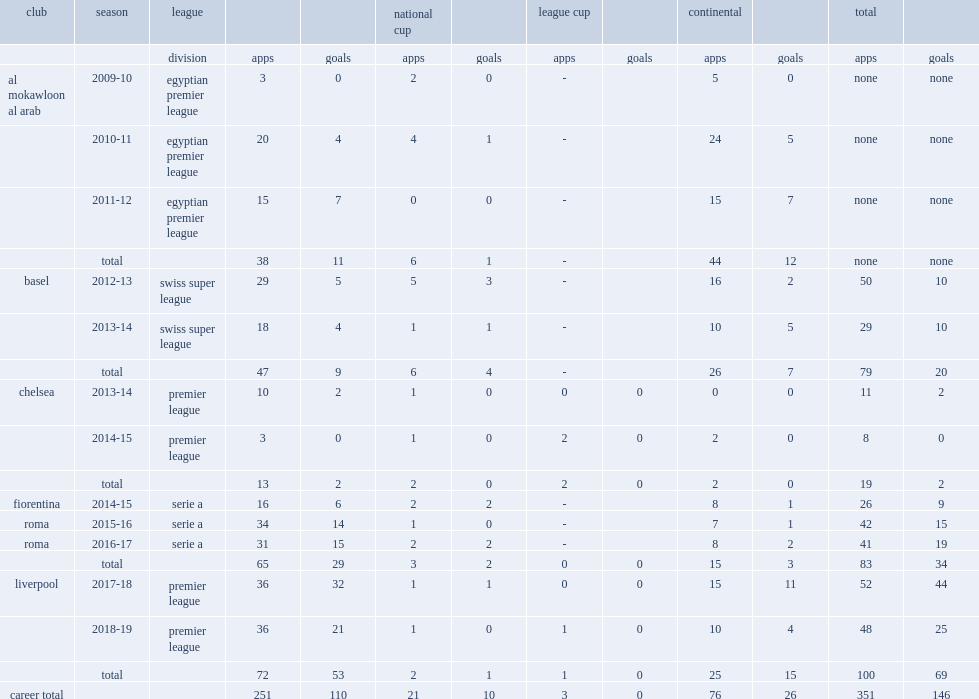Which club did salah play for in 2013-14? Basel. 